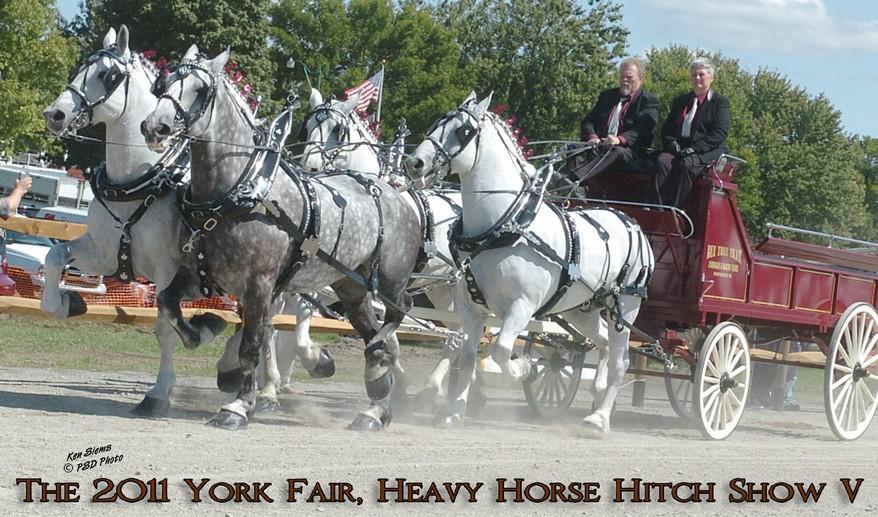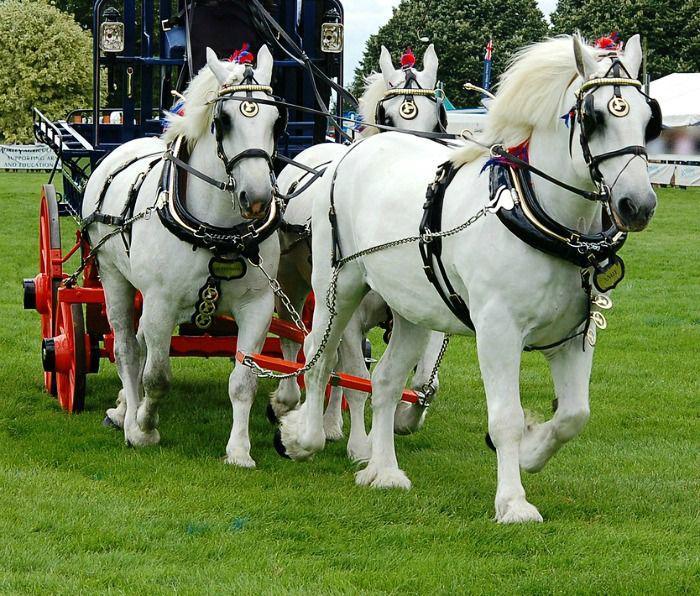The first image is the image on the left, the second image is the image on the right. Given the left and right images, does the statement "One image shows a wagon being pulled by four horses." hold true? Answer yes or no. Yes. The first image is the image on the left, the second image is the image on the right. For the images displayed, is the sentence "The horses in the image on the right are pulling a red carriage." factually correct? Answer yes or no. Yes. 